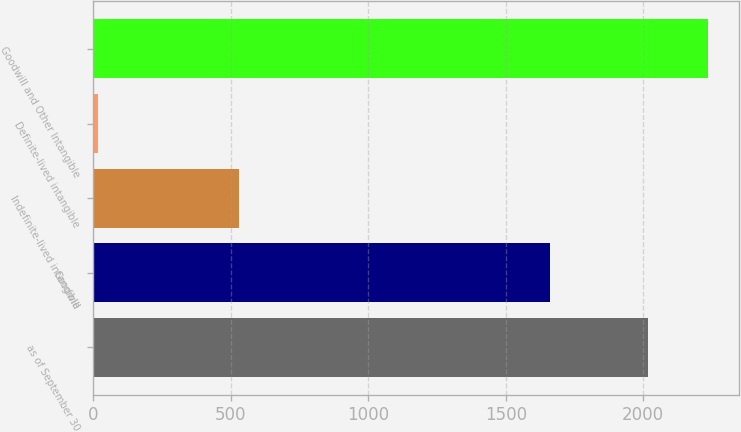Convert chart. <chart><loc_0><loc_0><loc_500><loc_500><bar_chart><fcel>as of September 30<fcel>Goodwill<fcel>Indefinite-lived intangible<fcel>Definite-lived intangible<fcel>Goodwill and Other Intangible<nl><fcel>2016<fcel>1661.2<fcel>530.9<fcel>19.2<fcel>2235.21<nl></chart> 